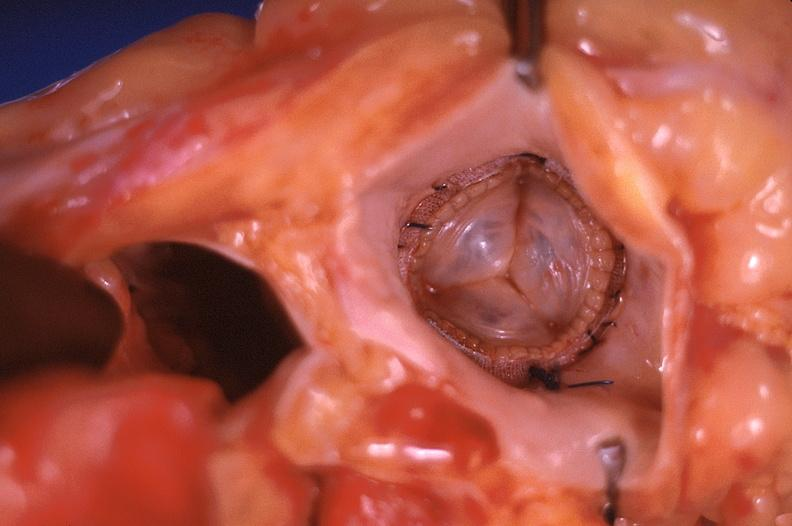s this image shows of smooth muscle cell with lipid in sarcoplasm and lipid present?
Answer the question using a single word or phrase. No 